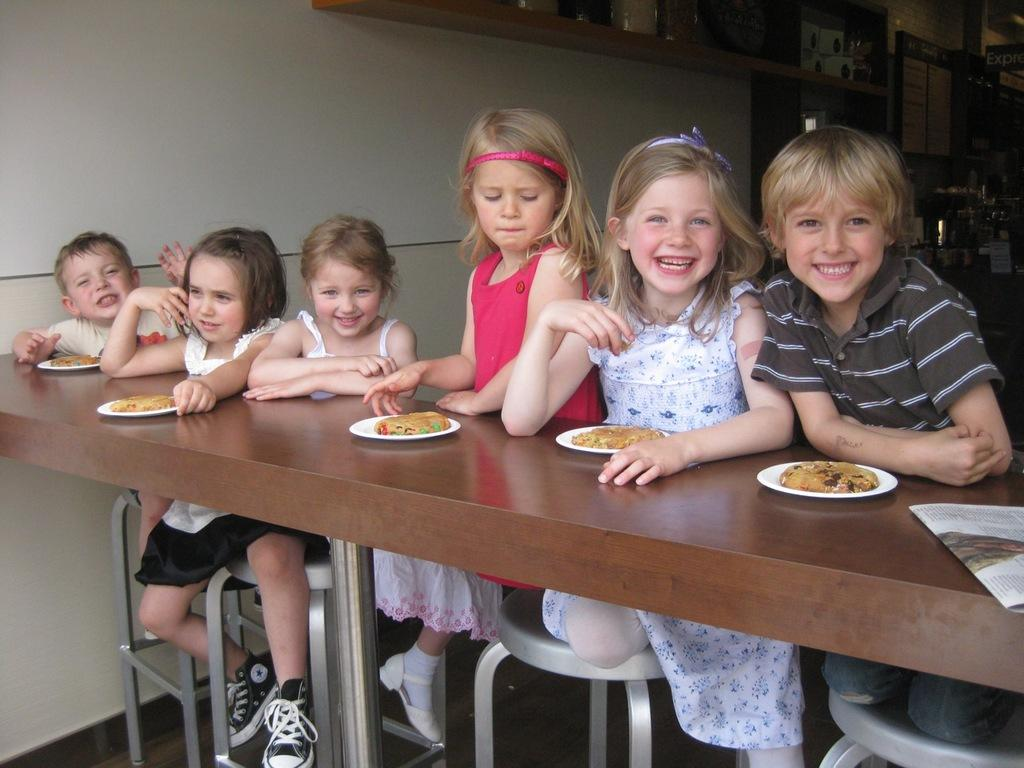Who is present in the image? There are children in the image. What are the children doing in the image? The children are sitting on chairs. What is in front of the children? There is a table in front of the children. How many plates with food are on the table? There are 5 plates with food on the table. What type of hat is the passenger wearing in the image? There is no passenger or hat present in the image; it features children sitting at a table with plates of food. 